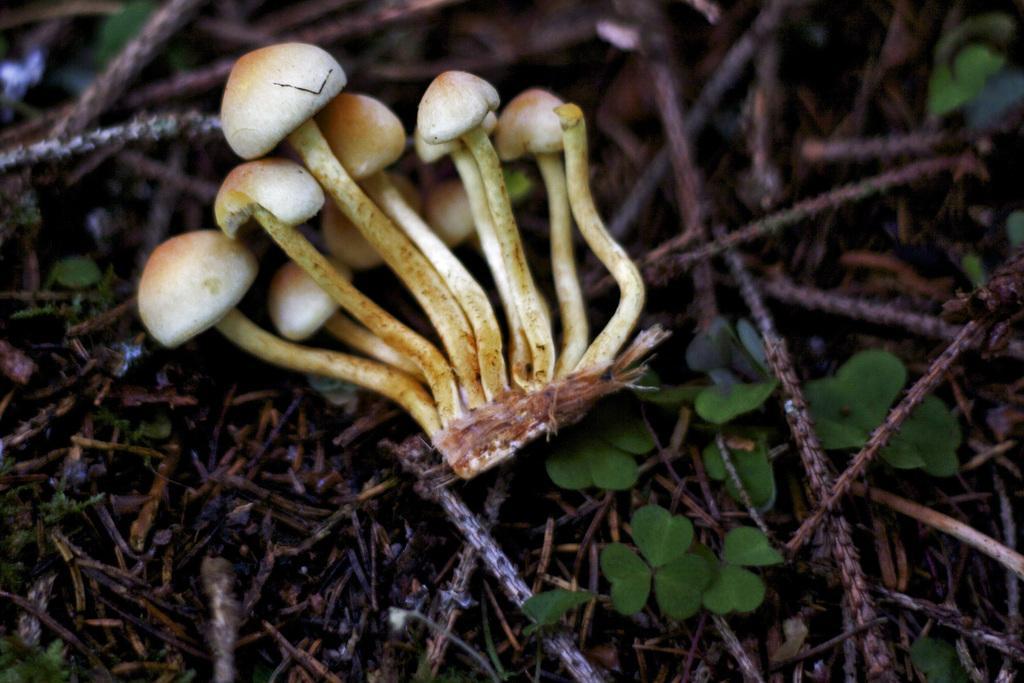Can you describe this image briefly? This image consists of small mushrooms on the ground. At the bottom, there are dried stems along with small leaves. 